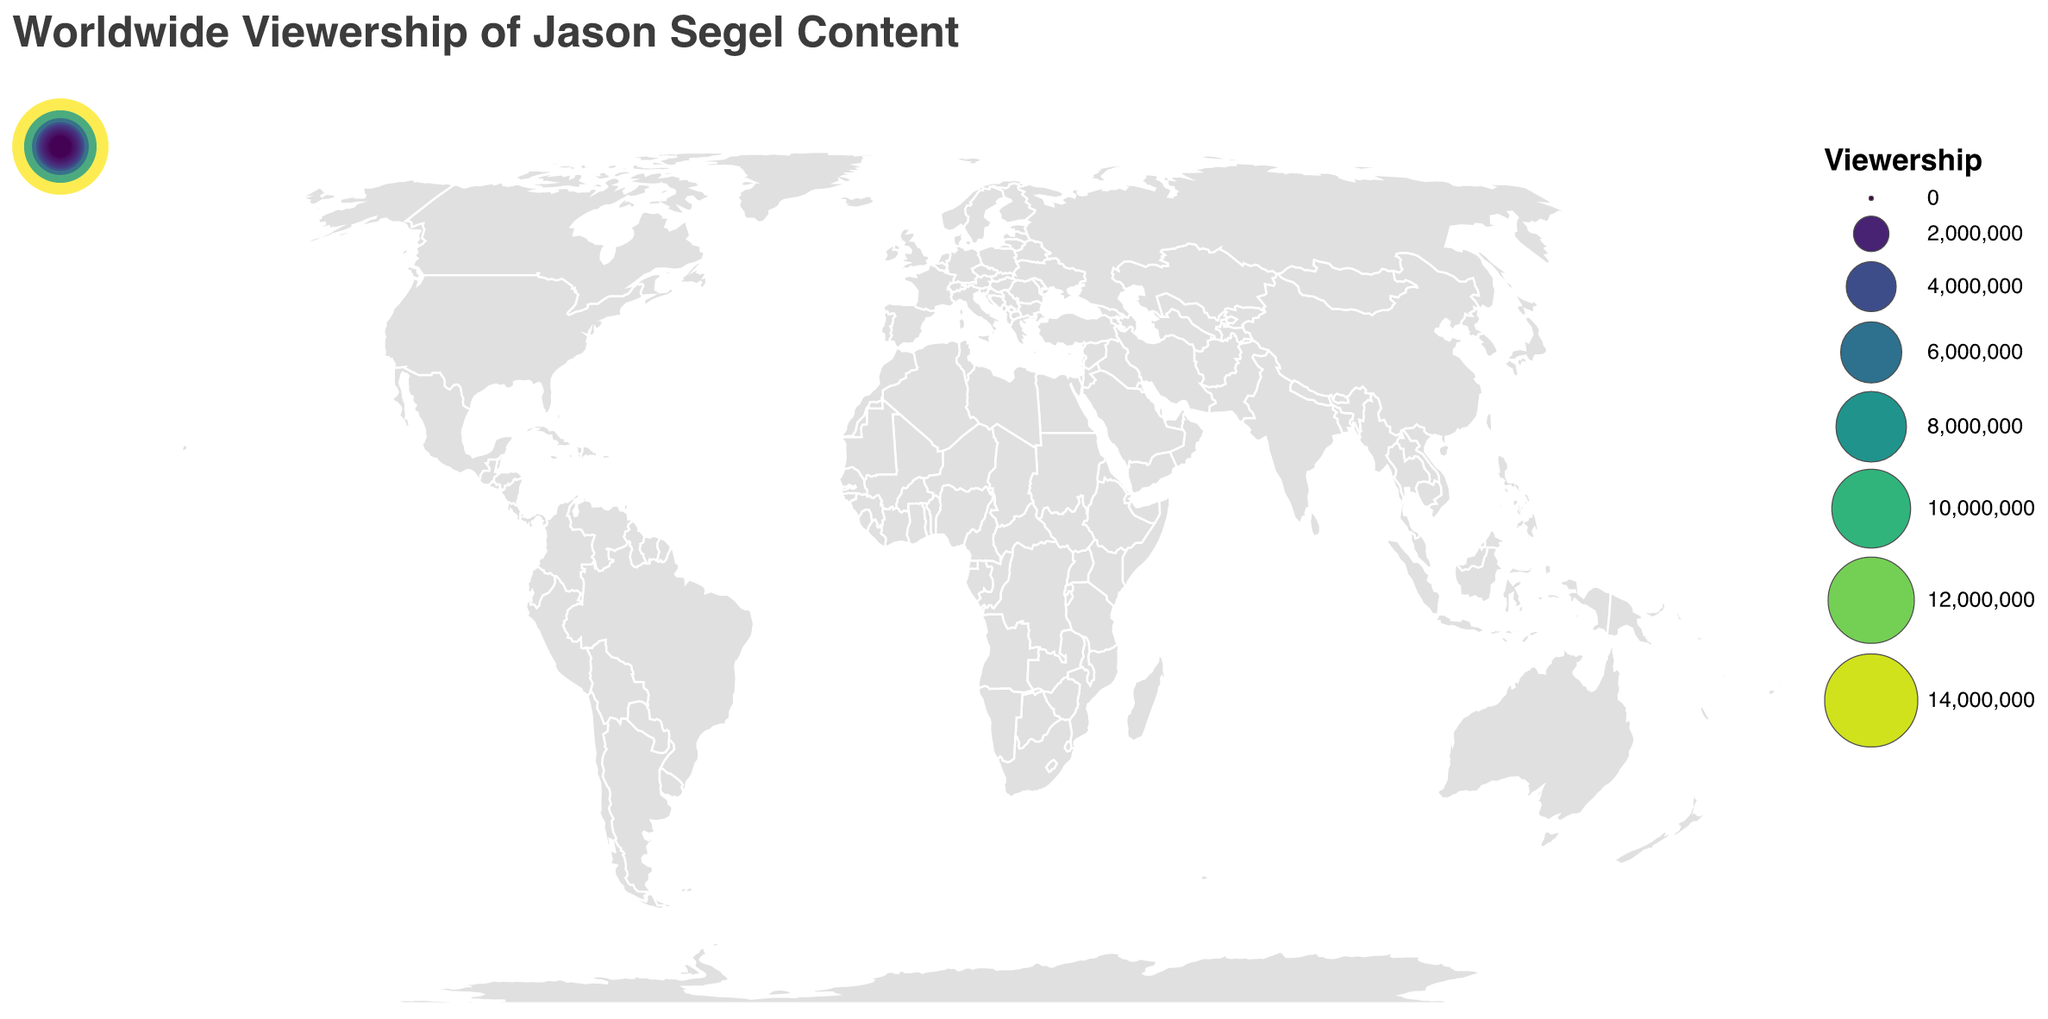What is the title of the geographic plot? The title of the plot is clearly displayed at the top. It reads "Worldwide Viewership of Jason Segel Content."
Answer: Worldwide Viewership of Jason Segel Content Which country has the highest viewership for Jason Segel content? By observing the size and color intensity of the circles in the plot, the United States has the highest viewership.
Answer: United States How many countries have a viewership exceeding 5 million? By counting the number of circles that are fairly large and have intense colors representing over 5 million viewership, we can see that the United States, United Kingdom, and Canada meet this criteria.
Answer: 3 What is the combined viewership in Australia, Germany, and France? Add the viewership numbers for Australia (3,800,000), Germany (3,200,000), and France (2,900,000). The combined viewership is 3,800,000 + 3,200,000 + 2,900,000 = 9,900,000.
Answer: 9,900,000 Which country in Europe has the lowest viewership for Jason Segel content, and what is that viewership amount? In Europe, the country with the smallest circle and least intense color is Italy, with a viewership of 850,000.
Answer: Italy, 850,000 Is there a significant difference in viewership between Brazil and Japan? If so, what is the difference? Comparing the viewership numbers for Brazil (2,500,000) and Japan (2,200,000), subtract Japan's viewership from Brazil's. The difference is 2,500,000 - 2,200,000 = 300,000.
Answer: Yes, 300,000 What is the average viewership for all the listed countries? Add all the viewership numbers: (15,000,000 + 8,500,000 + 5,200,000 + 3,800,000 + 3,200,000 + 2,900,000 + 2,500,000 + 2,200,000 + 1,900,000 + 1,700,000 + 1,500,000 + 1,200,000 + 900,000 + 850,000 + 700,000) and divide by the number of countries (15). The sum is 51,050,000, and the average is 51,050,000 / 15 ≈ 3,403,333.
Answer: 3,403,333 Which countries have 'Forgetting Sarah Marshall' listed as part of the Jason Segel content they view? By checking the tooltips or data labels, the countries with 'Forgetting Sarah Marshall' listed as Jason Segel content are the United States, Brazil, and Netherlands.
Answer: United States, Brazil, Netherlands What is the viewership of 'How I Met Your Mother' in India, and how does it compare to the viewership in Germany? Both countries list 'How I Met Your Mother' as part of their Jason Segel content. India's total viewership is 1,700,000, and Germany's is 3,200,000. The difference is 3,200,000 - 1,700,000 = 1,500,000.
Answer: 1,700,000; Germany has 1,500,000 more viewership 